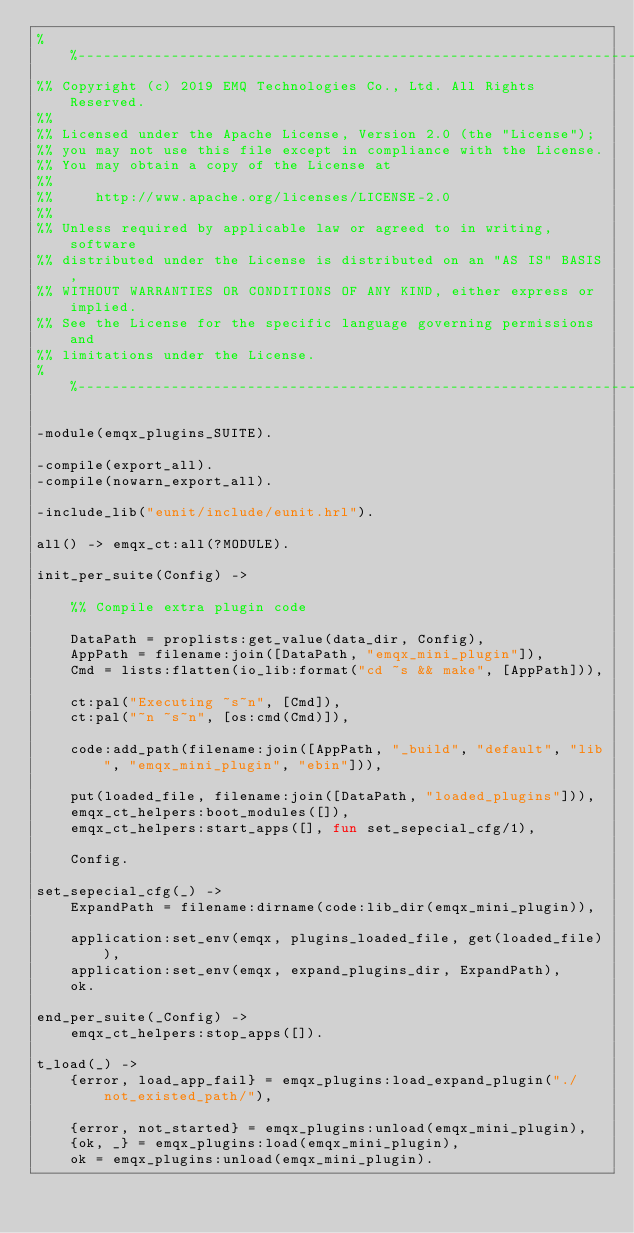Convert code to text. <code><loc_0><loc_0><loc_500><loc_500><_Erlang_>%%--------------------------------------------------------------------
%% Copyright (c) 2019 EMQ Technologies Co., Ltd. All Rights Reserved.
%%
%% Licensed under the Apache License, Version 2.0 (the "License");
%% you may not use this file except in compliance with the License.
%% You may obtain a copy of the License at
%%
%%     http://www.apache.org/licenses/LICENSE-2.0
%%
%% Unless required by applicable law or agreed to in writing, software
%% distributed under the License is distributed on an "AS IS" BASIS,
%% WITHOUT WARRANTIES OR CONDITIONS OF ANY KIND, either express or implied.
%% See the License for the specific language governing permissions and
%% limitations under the License.
%%--------------------------------------------------------------------

-module(emqx_plugins_SUITE).

-compile(export_all).
-compile(nowarn_export_all).

-include_lib("eunit/include/eunit.hrl").

all() -> emqx_ct:all(?MODULE).

init_per_suite(Config) ->

    %% Compile extra plugin code

    DataPath = proplists:get_value(data_dir, Config),
    AppPath = filename:join([DataPath, "emqx_mini_plugin"]),
    Cmd = lists:flatten(io_lib:format("cd ~s && make", [AppPath])),

    ct:pal("Executing ~s~n", [Cmd]),
    ct:pal("~n ~s~n", [os:cmd(Cmd)]),

    code:add_path(filename:join([AppPath, "_build", "default", "lib", "emqx_mini_plugin", "ebin"])),

    put(loaded_file, filename:join([DataPath, "loaded_plugins"])),
    emqx_ct_helpers:boot_modules([]),
    emqx_ct_helpers:start_apps([], fun set_sepecial_cfg/1),

    Config.

set_sepecial_cfg(_) ->
    ExpandPath = filename:dirname(code:lib_dir(emqx_mini_plugin)),

    application:set_env(emqx, plugins_loaded_file, get(loaded_file)),
    application:set_env(emqx, expand_plugins_dir, ExpandPath),
    ok.

end_per_suite(_Config) ->
    emqx_ct_helpers:stop_apps([]).

t_load(_) ->
    {error, load_app_fail} = emqx_plugins:load_expand_plugin("./not_existed_path/"),

    {error, not_started} = emqx_plugins:unload(emqx_mini_plugin),
    {ok, _} = emqx_plugins:load(emqx_mini_plugin),
    ok = emqx_plugins:unload(emqx_mini_plugin).
</code> 